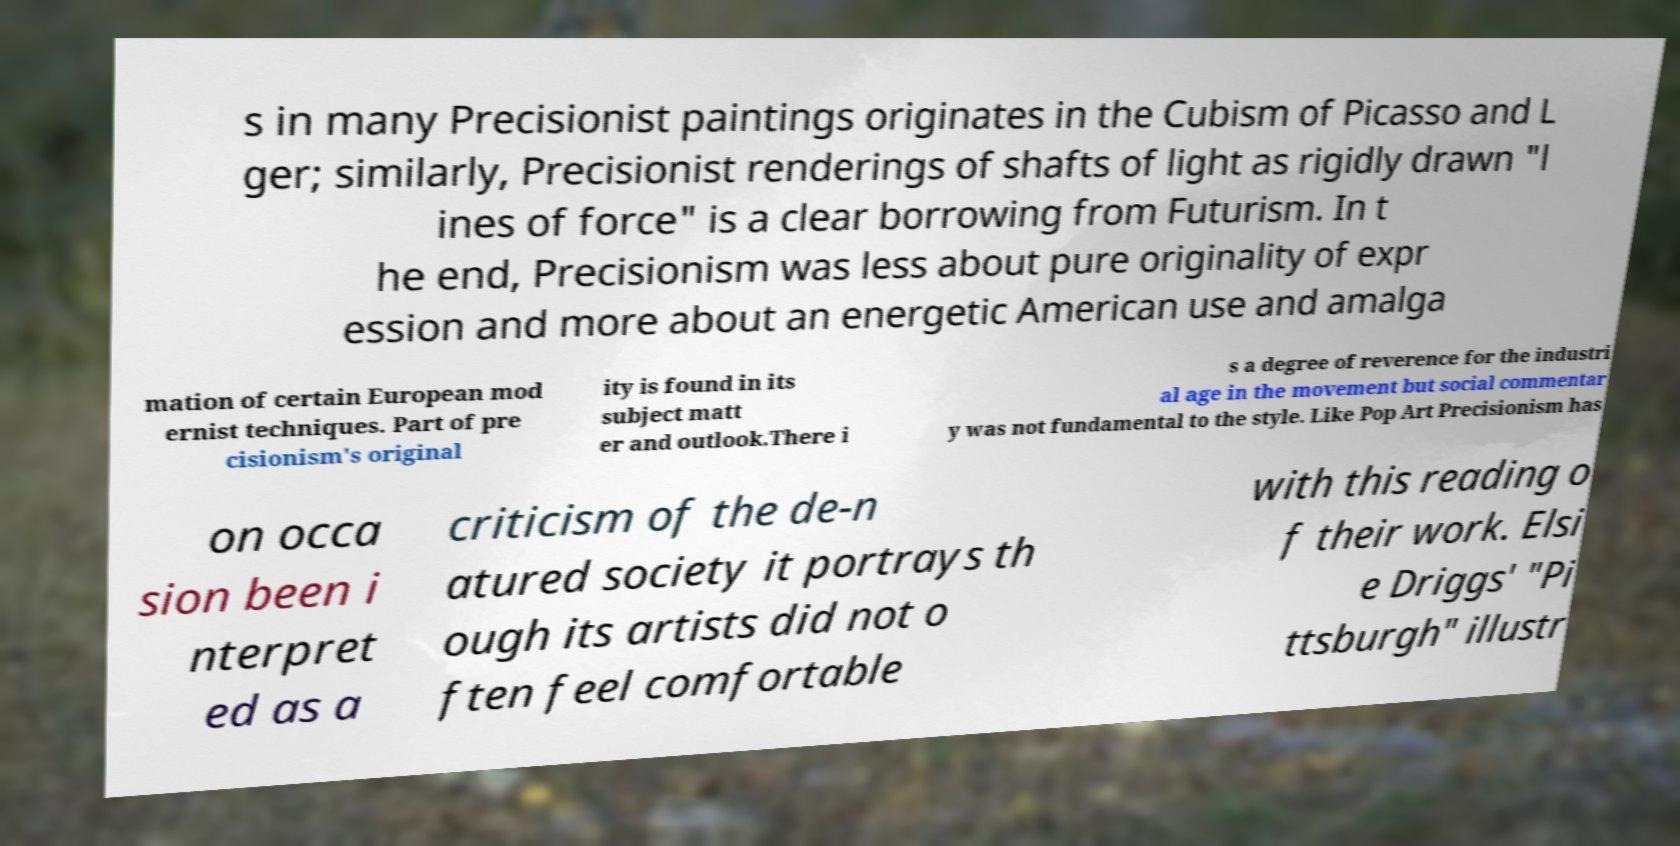Please identify and transcribe the text found in this image. s in many Precisionist paintings originates in the Cubism of Picasso and L ger; similarly, Precisionist renderings of shafts of light as rigidly drawn "l ines of force" is a clear borrowing from Futurism. In t he end, Precisionism was less about pure originality of expr ession and more about an energetic American use and amalga mation of certain European mod ernist techniques. Part of pre cisionism's original ity is found in its subject matt er and outlook.There i s a degree of reverence for the industri al age in the movement but social commentar y was not fundamental to the style. Like Pop Art Precisionism has on occa sion been i nterpret ed as a criticism of the de-n atured society it portrays th ough its artists did not o ften feel comfortable with this reading o f their work. Elsi e Driggs' "Pi ttsburgh" illustr 